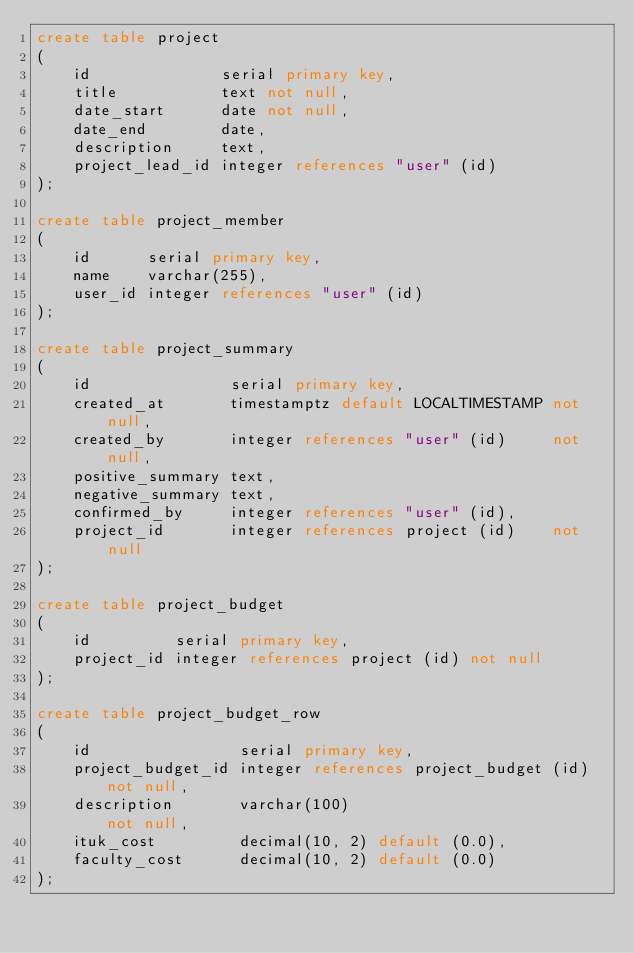Convert code to text. <code><loc_0><loc_0><loc_500><loc_500><_SQL_>create table project
(
    id              serial primary key,
    title           text not null,
    date_start      date not null,
    date_end        date,
    description     text,
    project_lead_id integer references "user" (id)
);

create table project_member
(
    id      serial primary key,
    name    varchar(255),
    user_id integer references "user" (id)
);

create table project_summary
(
    id               serial primary key,
    created_at       timestamptz default LOCALTIMESTAMP not null,
    created_by       integer references "user" (id)     not null,
    positive_summary text,
    negative_summary text,
    confirmed_by     integer references "user" (id),
    project_id       integer references project (id)    not null
);

create table project_budget
(
    id         serial primary key,
    project_id integer references project (id) not null
);

create table project_budget_row
(
    id                serial primary key,
    project_budget_id integer references project_budget (id) not null,
    description       varchar(100)                           not null,
    ituk_cost         decimal(10, 2) default (0.0),
    faculty_cost      decimal(10, 2) default (0.0)
);
</code> 